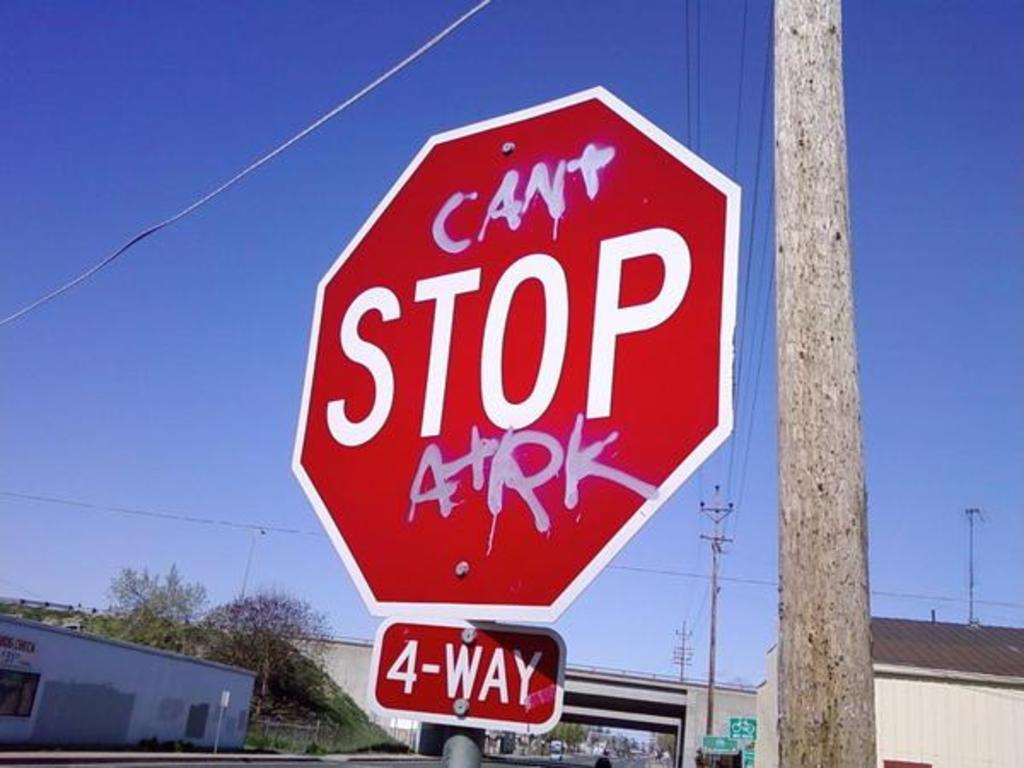<image>
Write a terse but informative summary of the picture. A four way stop sign with graffiti on it. 